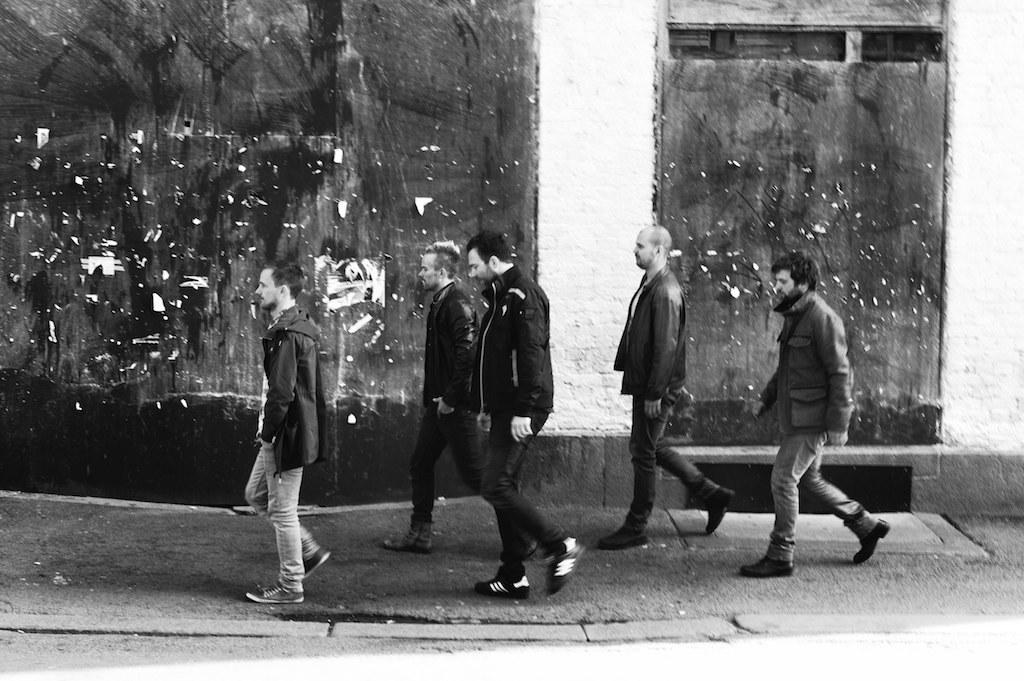What is the color scheme of the image? The image is black and white. What are the people in the image doing? People are walking on the road in the image. What can be seen in the background of the image? There is a wall at the back side of the image. What type of mine can be seen in the image? There is no mine present in the image; it is a black and white image of people walking on a road with a wall in the background. 